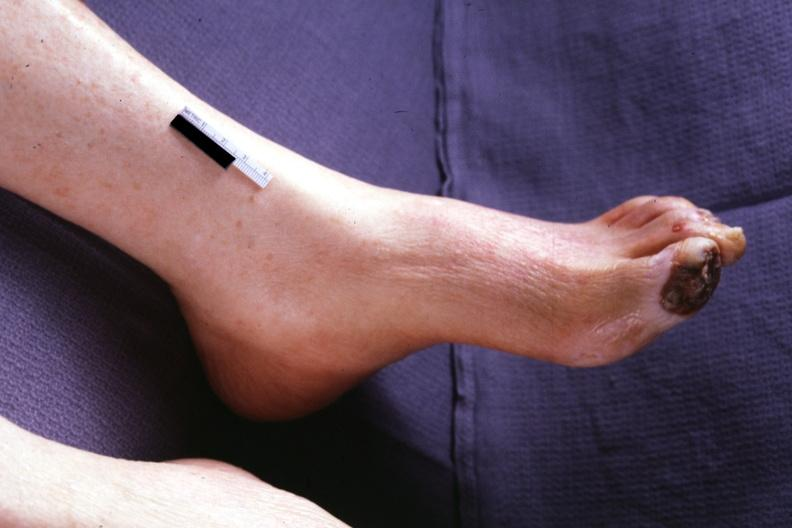what are present?
Answer the question using a single word or phrase. Extremities 